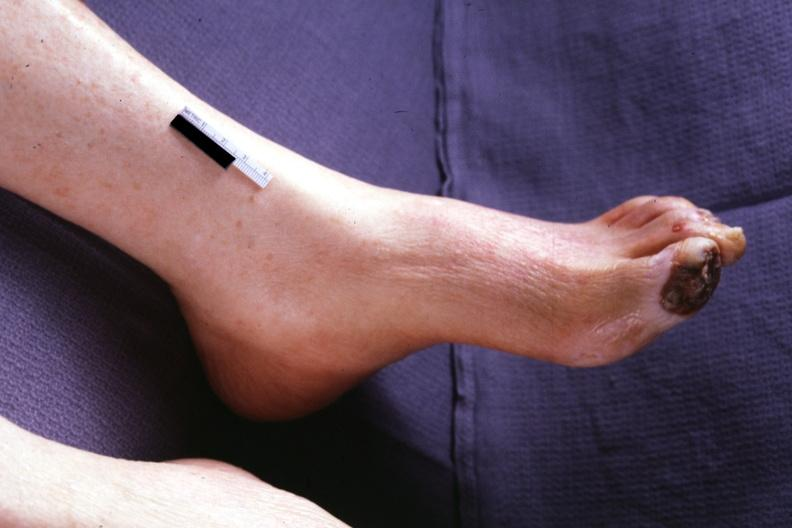what are present?
Answer the question using a single word or phrase. Extremities 